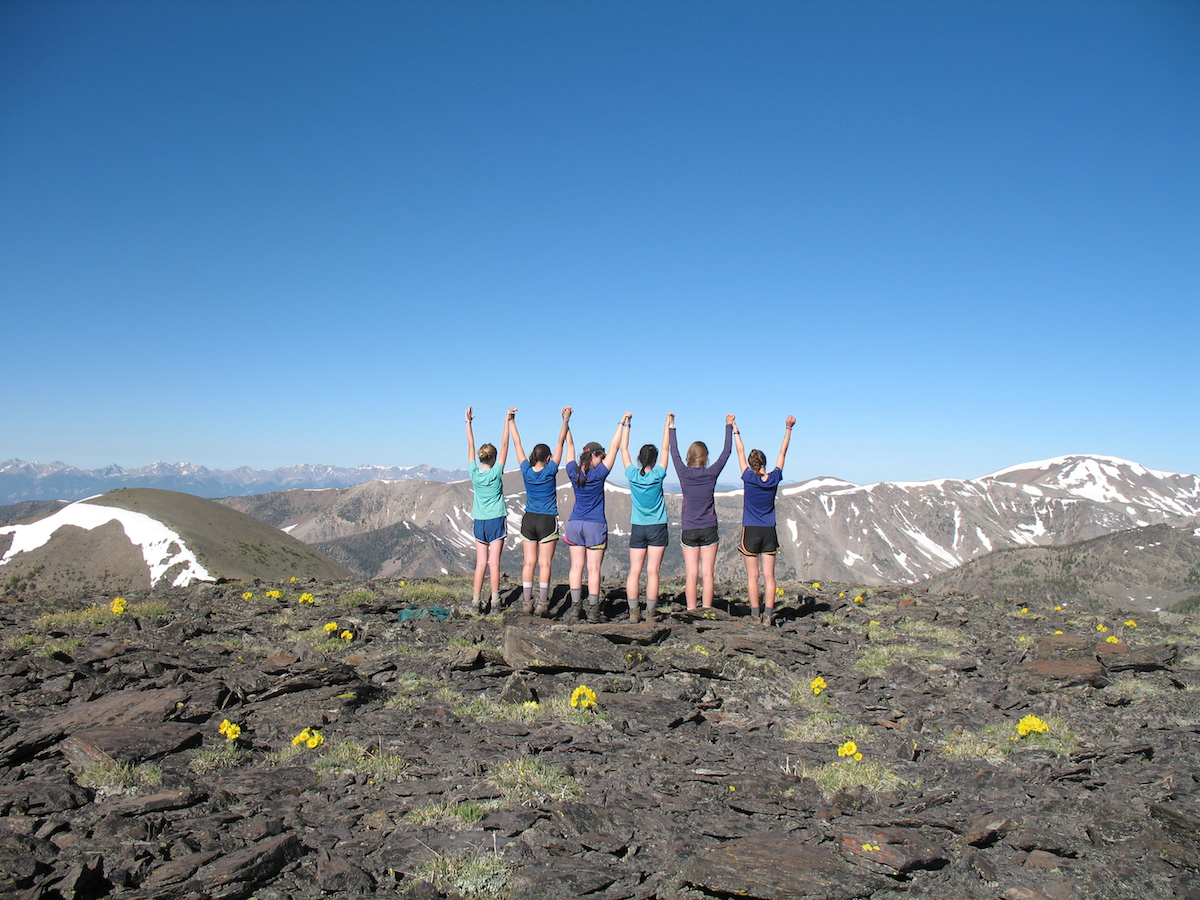What might be the significance of the group's pose in this setting? The group's pose, with their arms raised and bodies aligned, facing towards the vast mountain backdrop, expresses a sense of triumph and unity. This pose typically symbolizes achievement and celebration, likely suggesting they have reached a significant point in their hike or journey. The pose and the setting together may emphasize themes of overcoming challenges, teamwork, or enjoying a shared experience amidst the beauty of natural landscapes. 